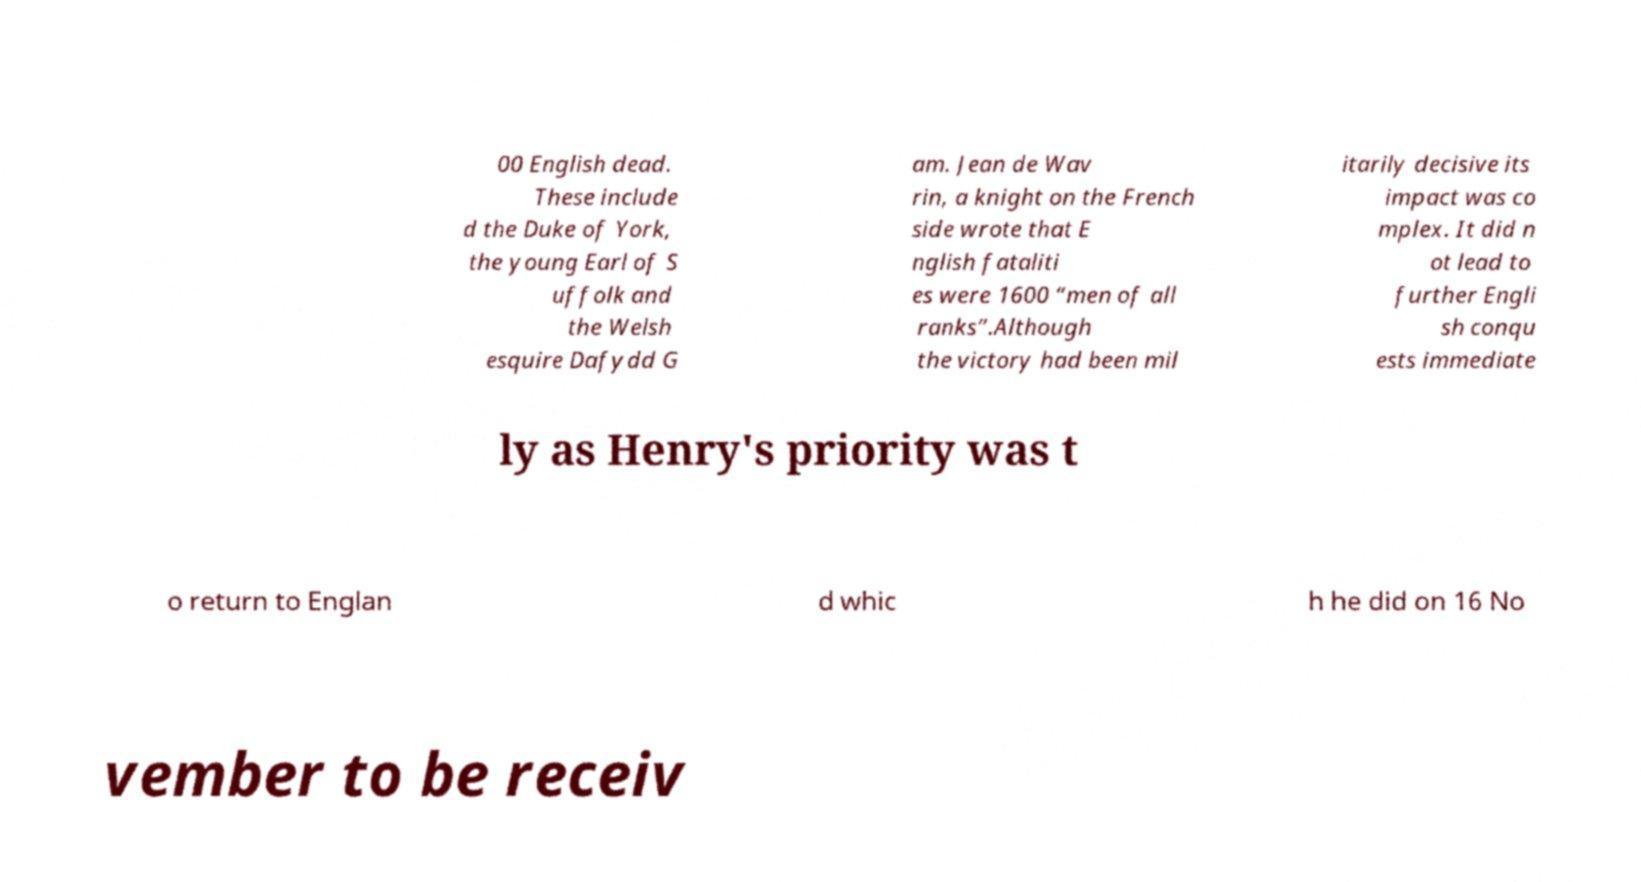Please read and relay the text visible in this image. What does it say? 00 English dead. These include d the Duke of York, the young Earl of S uffolk and the Welsh esquire Dafydd G am. Jean de Wav rin, a knight on the French side wrote that E nglish fataliti es were 1600 “men of all ranks”.Although the victory had been mil itarily decisive its impact was co mplex. It did n ot lead to further Engli sh conqu ests immediate ly as Henry's priority was t o return to Englan d whic h he did on 16 No vember to be receiv 